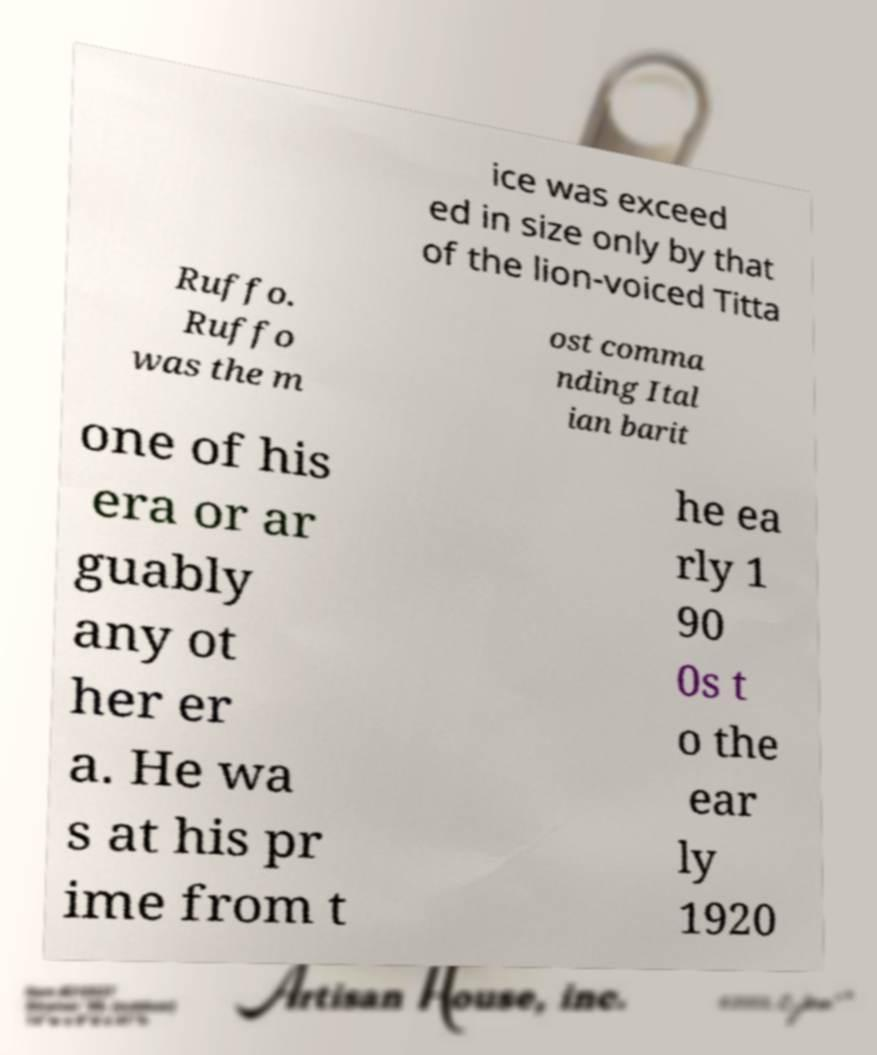Could you assist in decoding the text presented in this image and type it out clearly? ice was exceed ed in size only by that of the lion-voiced Titta Ruffo. Ruffo was the m ost comma nding Ital ian barit one of his era or ar guably any ot her er a. He wa s at his pr ime from t he ea rly 1 90 0s t o the ear ly 1920 